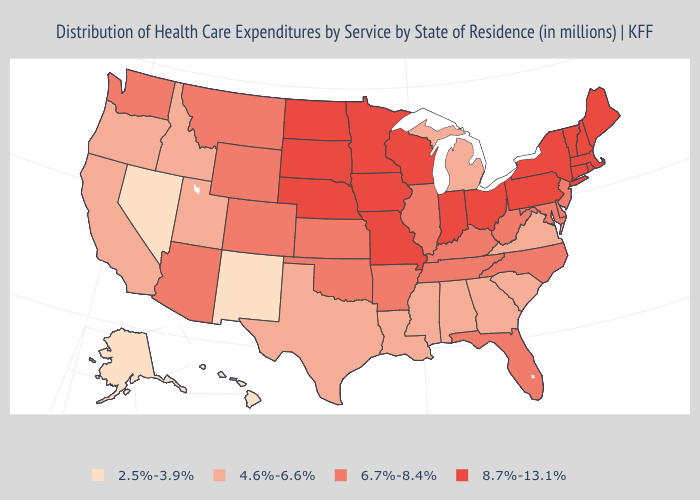What is the lowest value in states that border Nevada?
Concise answer only. 4.6%-6.6%. What is the value of Michigan?
Short answer required. 4.6%-6.6%. What is the highest value in the South ?
Answer briefly. 6.7%-8.4%. Name the states that have a value in the range 8.7%-13.1%?
Quick response, please. Connecticut, Indiana, Iowa, Maine, Massachusetts, Minnesota, Missouri, Nebraska, New Hampshire, New York, North Dakota, Ohio, Pennsylvania, Rhode Island, South Dakota, Vermont, Wisconsin. What is the value of Virginia?
Concise answer only. 4.6%-6.6%. Which states have the lowest value in the USA?
Concise answer only. Alaska, Hawaii, Nevada, New Mexico. What is the lowest value in states that border Oklahoma?
Quick response, please. 2.5%-3.9%. What is the lowest value in the South?
Short answer required. 4.6%-6.6%. Does Nevada have the lowest value in the USA?
Give a very brief answer. Yes. Does South Carolina have the highest value in the South?
Answer briefly. No. What is the value of Wyoming?
Answer briefly. 6.7%-8.4%. Does the map have missing data?
Answer briefly. No. Name the states that have a value in the range 8.7%-13.1%?
Concise answer only. Connecticut, Indiana, Iowa, Maine, Massachusetts, Minnesota, Missouri, Nebraska, New Hampshire, New York, North Dakota, Ohio, Pennsylvania, Rhode Island, South Dakota, Vermont, Wisconsin. Does New Jersey have the highest value in the Northeast?
Answer briefly. No. What is the value of Rhode Island?
Write a very short answer. 8.7%-13.1%. 